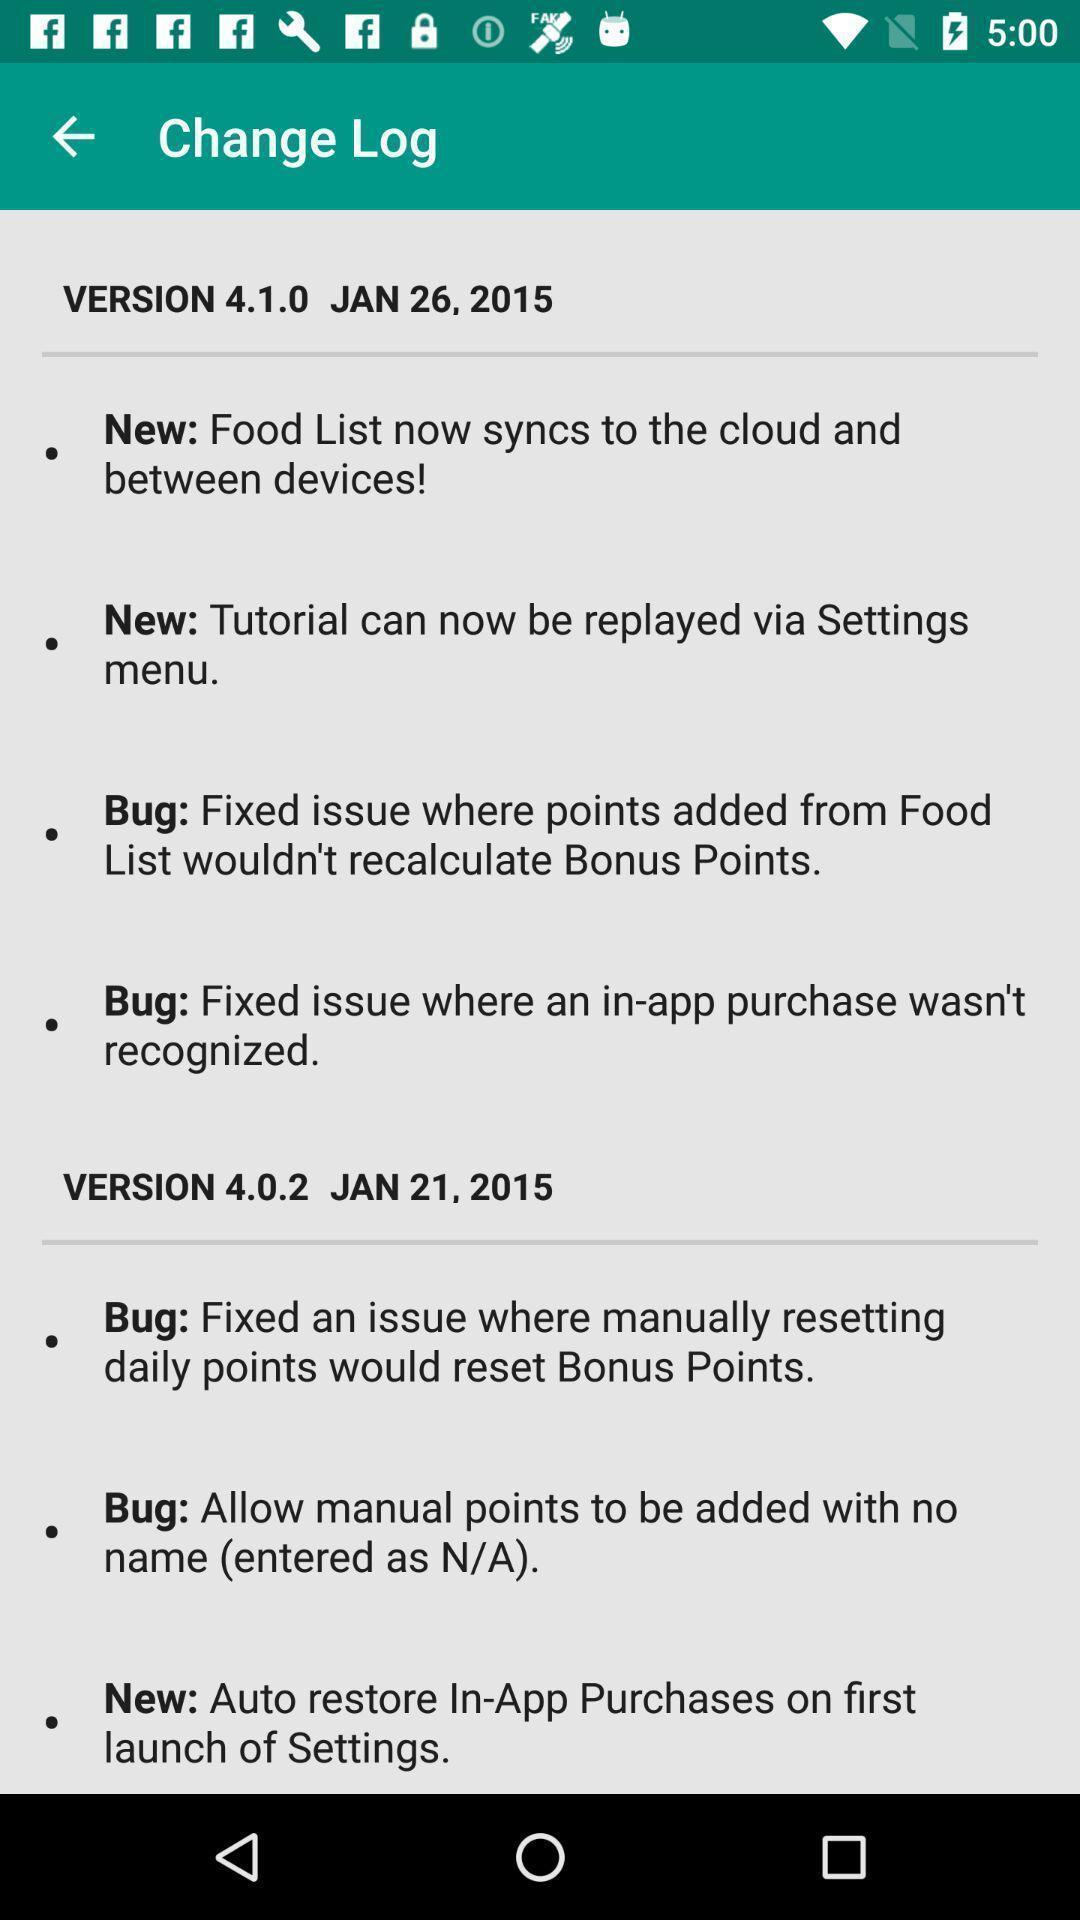Describe the content in this image. Updated information. 